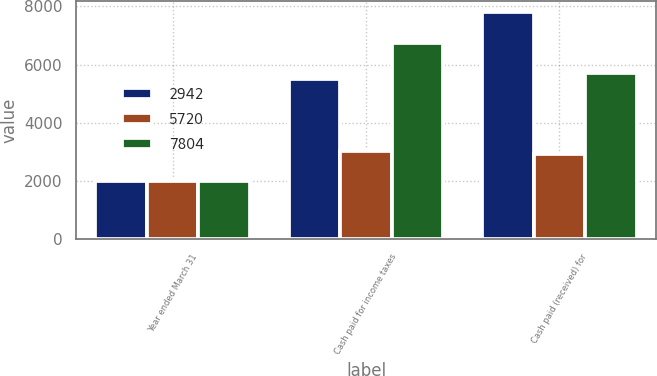<chart> <loc_0><loc_0><loc_500><loc_500><stacked_bar_chart><ecel><fcel>Year ended March 31<fcel>Cash paid for income taxes<fcel>Cash paid (received) for<nl><fcel>2942<fcel>2003<fcel>5491<fcel>7804<nl><fcel>5720<fcel>2002<fcel>3041<fcel>2942<nl><fcel>7804<fcel>2001<fcel>6753<fcel>5720<nl></chart> 